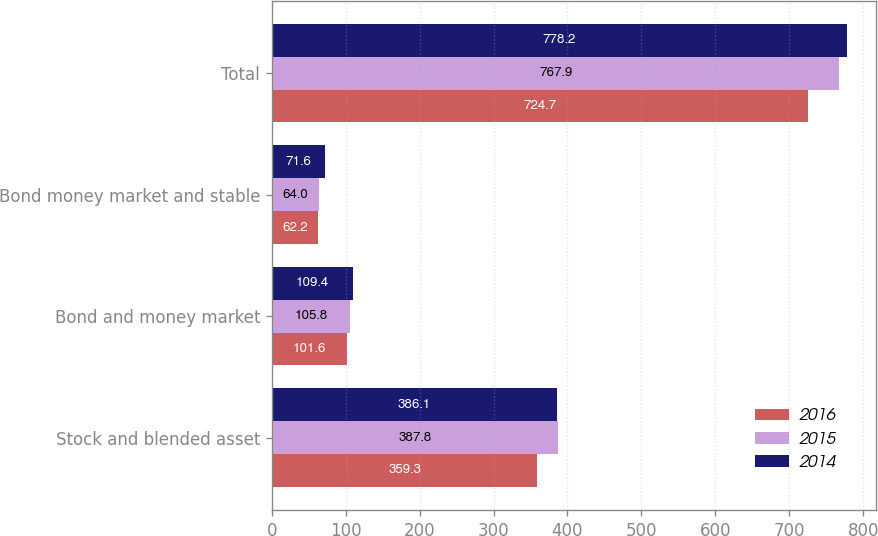Convert chart to OTSL. <chart><loc_0><loc_0><loc_500><loc_500><stacked_bar_chart><ecel><fcel>Stock and blended asset<fcel>Bond and money market<fcel>Bond money market and stable<fcel>Total<nl><fcel>2016<fcel>359.3<fcel>101.6<fcel>62.2<fcel>724.7<nl><fcel>2015<fcel>387.8<fcel>105.8<fcel>64<fcel>767.9<nl><fcel>2014<fcel>386.1<fcel>109.4<fcel>71.6<fcel>778.2<nl></chart> 